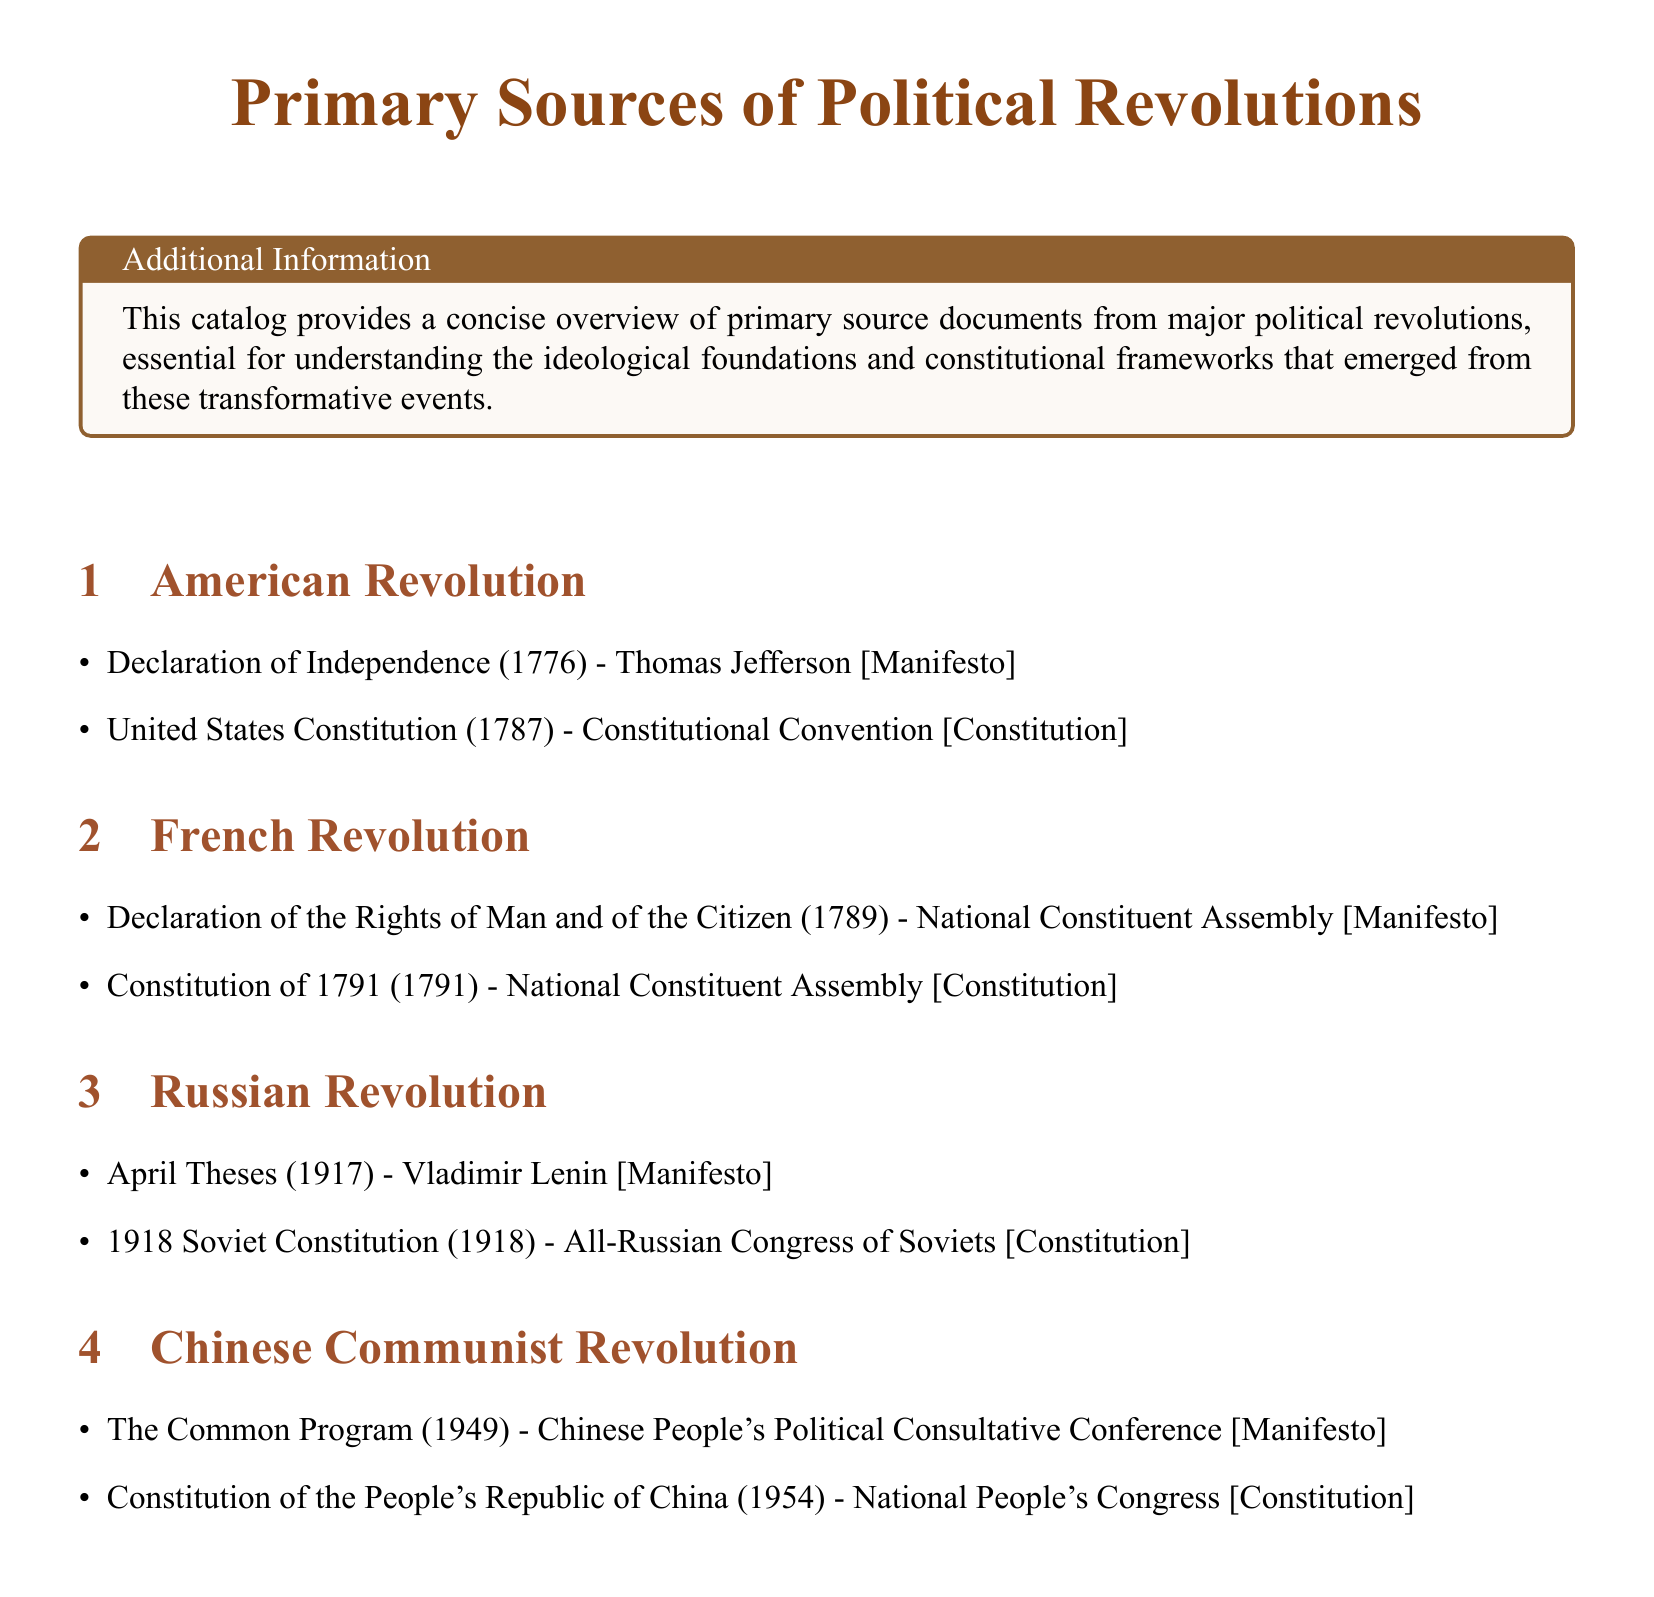What is the first document listed under the American Revolution? The first document under the American Revolution is the Declaration of Independence, which is a key manifesto.
Answer: Declaration of Independence (1776) Who authored the Declaration of the Rights of Man and of the Citizen? The Declaration of the Rights of Man and of the Citizen was authored by the National Constituent Assembly.
Answer: National Constituent Assembly What year was the United States Constitution adopted? The year the United States Constitution was adopted is essential information found in the document, which is 1787.
Answer: 1787 How many constitutions are listed in the catalog? The number of constitutions mentioned in the catalog can be counted from the sections relating to each revolution, which totals four.
Answer: 4 Which document is known for presenting Lenin's ideas during the Russian Revolution? The document known for presenting Lenin's ideas during the Russian Revolution is the April Theses.
Answer: April Theses (1917) What political event does the Common Program relate to? The Common Program relates to the Chinese Communist Revolution, indicating its historical significance.
Answer: Chinese Communist Revolution Which document was adopted by the National People's Congress in 1954? The document adopted by the National People's Congress in 1954 is a key constitutional text within the catalog.
Answer: Constitution of the People's Republic of China (1954) Which revolution is associated with the year 1791? The revolution associated with the year 1791 pertains to France, specifically the constitutional framework established then.
Answer: French Revolution 